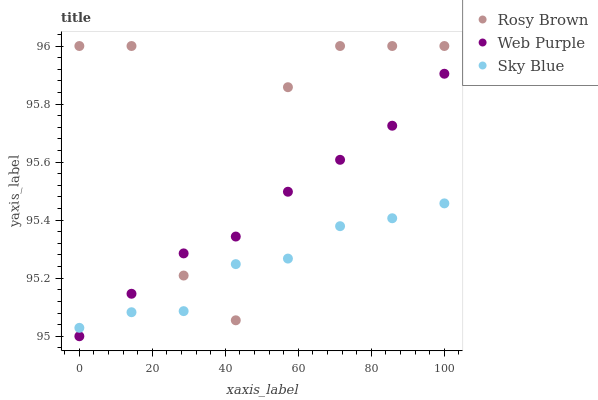Does Sky Blue have the minimum area under the curve?
Answer yes or no. Yes. Does Rosy Brown have the maximum area under the curve?
Answer yes or no. Yes. Does Web Purple have the minimum area under the curve?
Answer yes or no. No. Does Web Purple have the maximum area under the curve?
Answer yes or no. No. Is Web Purple the smoothest?
Answer yes or no. Yes. Is Rosy Brown the roughest?
Answer yes or no. Yes. Is Rosy Brown the smoothest?
Answer yes or no. No. Is Web Purple the roughest?
Answer yes or no. No. Does Web Purple have the lowest value?
Answer yes or no. Yes. Does Rosy Brown have the lowest value?
Answer yes or no. No. Does Rosy Brown have the highest value?
Answer yes or no. Yes. Does Web Purple have the highest value?
Answer yes or no. No. Does Sky Blue intersect Web Purple?
Answer yes or no. Yes. Is Sky Blue less than Web Purple?
Answer yes or no. No. Is Sky Blue greater than Web Purple?
Answer yes or no. No. 